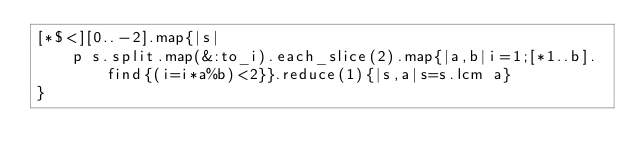Convert code to text. <code><loc_0><loc_0><loc_500><loc_500><_Ruby_>[*$<][0..-2].map{|s|
    p s.split.map(&:to_i).each_slice(2).map{|a,b|i=1;[*1..b].find{(i=i*a%b)<2}}.reduce(1){|s,a|s=s.lcm a}
}
</code> 